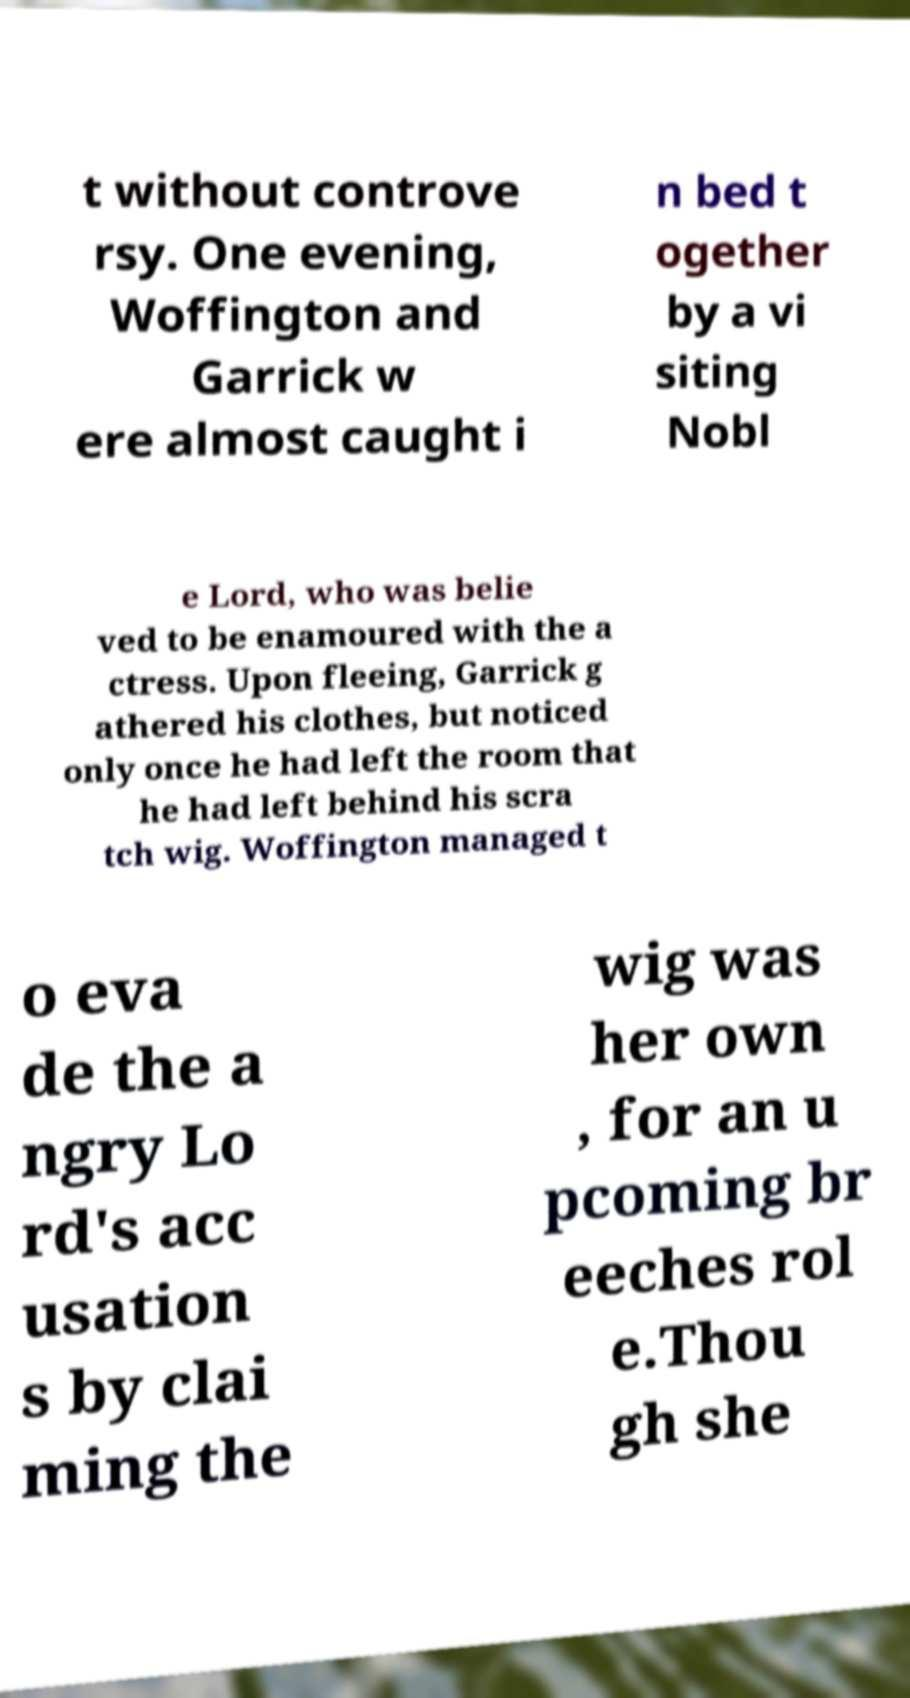Please identify and transcribe the text found in this image. t without controve rsy. One evening, Woffington and Garrick w ere almost caught i n bed t ogether by a vi siting Nobl e Lord, who was belie ved to be enamoured with the a ctress. Upon fleeing, Garrick g athered his clothes, but noticed only once he had left the room that he had left behind his scra tch wig. Woffington managed t o eva de the a ngry Lo rd's acc usation s by clai ming the wig was her own , for an u pcoming br eeches rol e.Thou gh she 